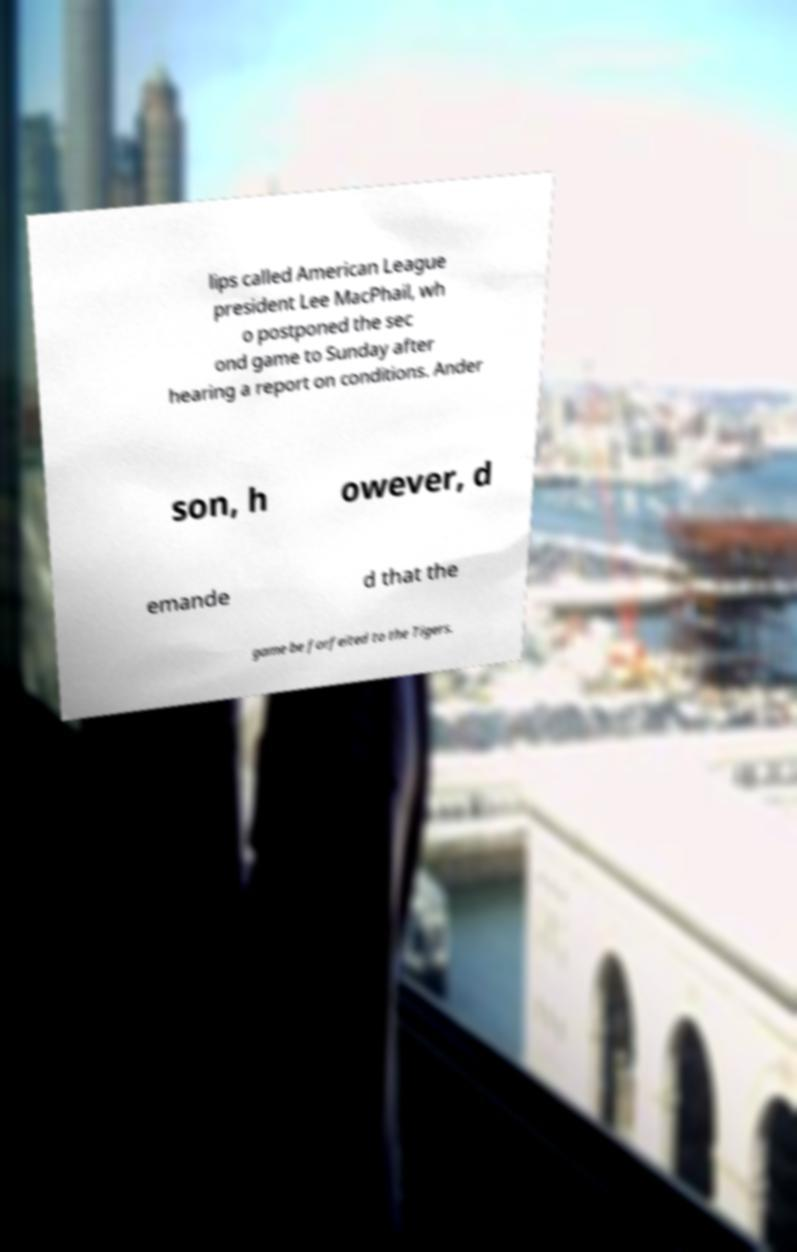Could you extract and type out the text from this image? lips called American League president Lee MacPhail, wh o postponed the sec ond game to Sunday after hearing a report on conditions. Ander son, h owever, d emande d that the game be forfeited to the Tigers. 